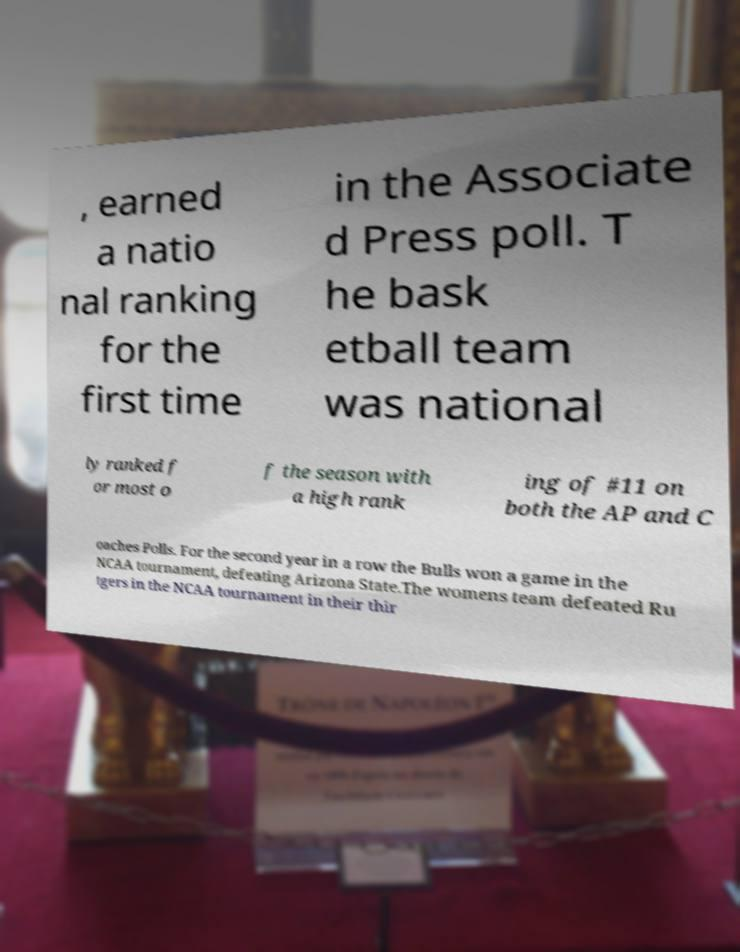Could you assist in decoding the text presented in this image and type it out clearly? , earned a natio nal ranking for the first time in the Associate d Press poll. T he bask etball team was national ly ranked f or most o f the season with a high rank ing of #11 on both the AP and C oaches Polls. For the second year in a row the Bulls won a game in the NCAA tournament, defeating Arizona State.The womens team defeated Ru tgers in the NCAA tournament in their thir 